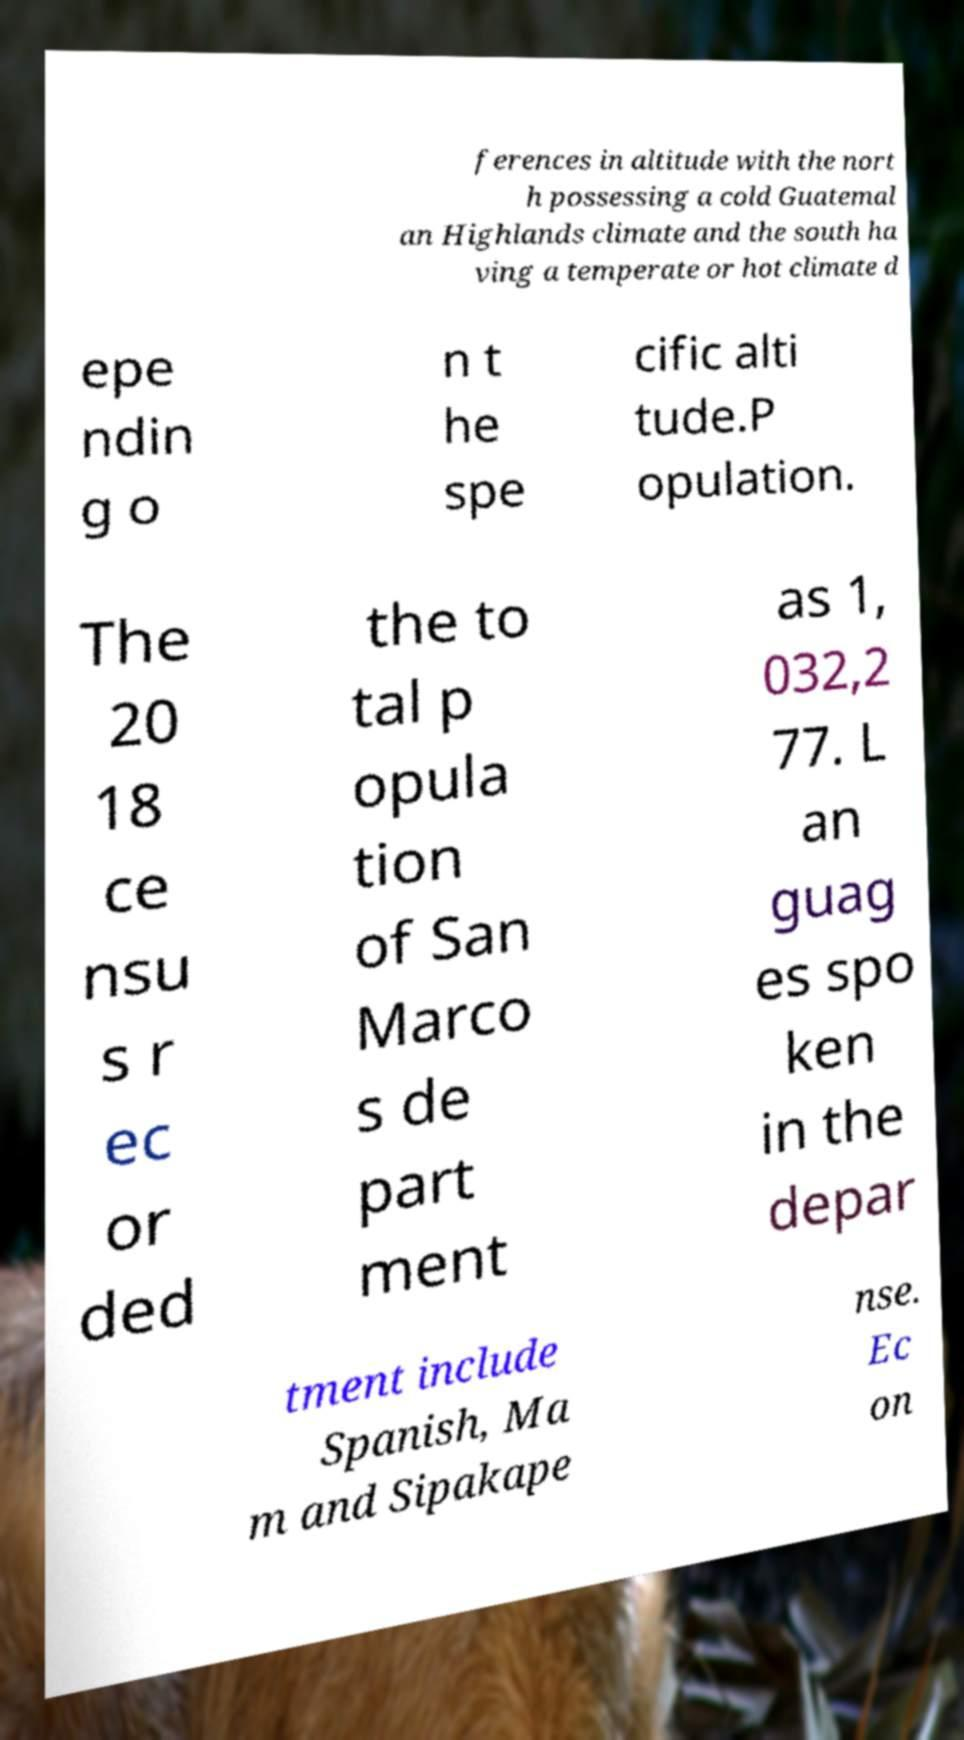Could you extract and type out the text from this image? ferences in altitude with the nort h possessing a cold Guatemal an Highlands climate and the south ha ving a temperate or hot climate d epe ndin g o n t he spe cific alti tude.P opulation. The 20 18 ce nsu s r ec or ded the to tal p opula tion of San Marco s de part ment as 1, 032,2 77. L an guag es spo ken in the depar tment include Spanish, Ma m and Sipakape nse. Ec on 